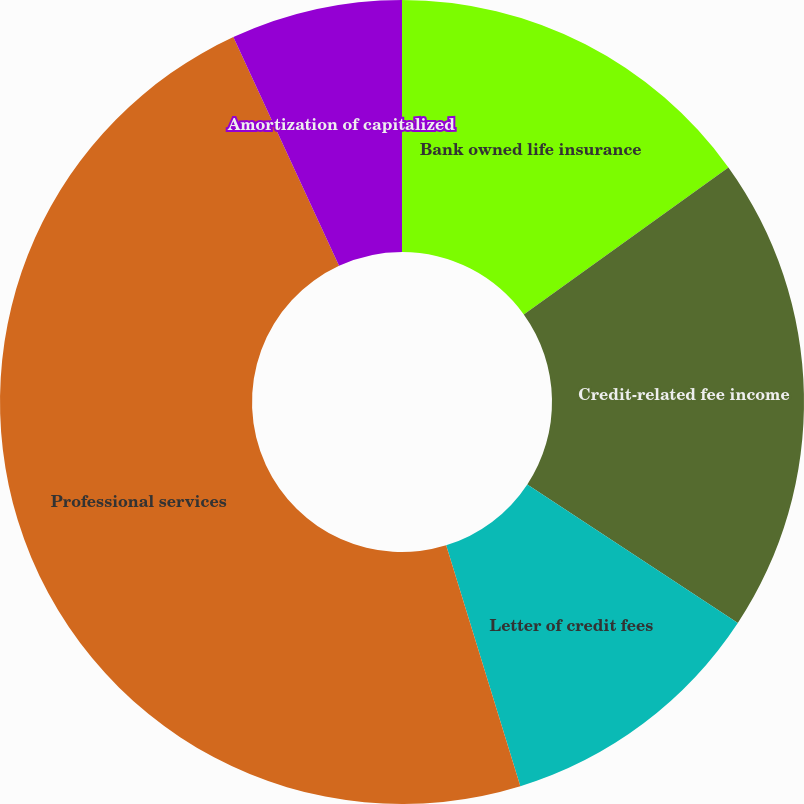<chart> <loc_0><loc_0><loc_500><loc_500><pie_chart><fcel>Bank owned life insurance<fcel>Credit-related fee income<fcel>Letter of credit fees<fcel>Professional services<fcel>Amortization of capitalized<nl><fcel>15.08%<fcel>19.18%<fcel>10.98%<fcel>47.86%<fcel>6.89%<nl></chart> 